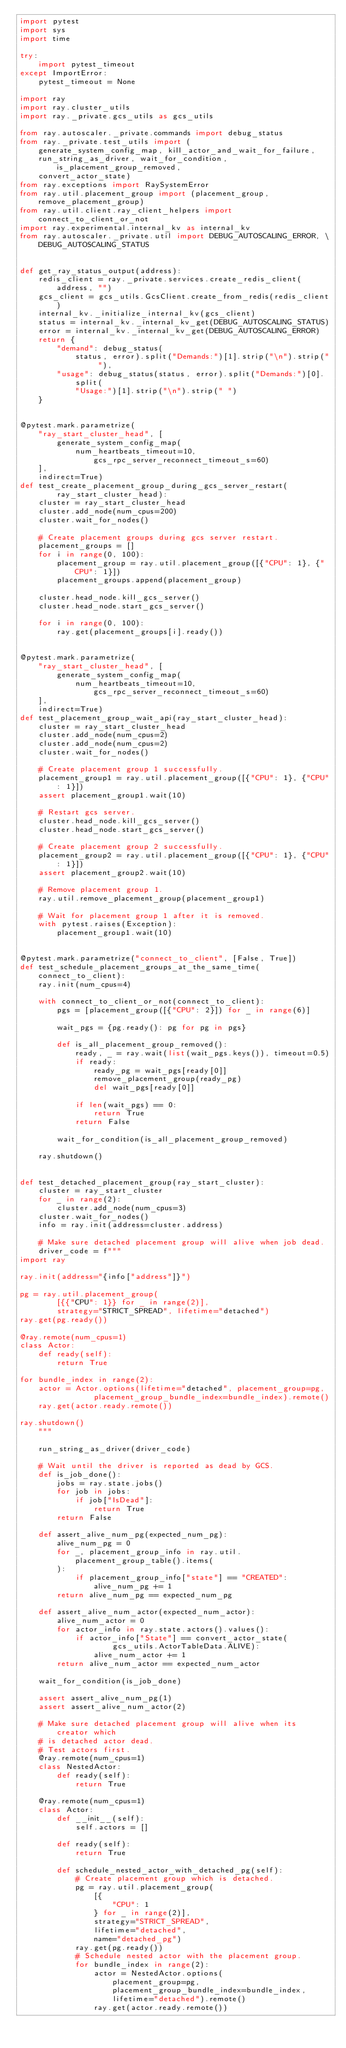<code> <loc_0><loc_0><loc_500><loc_500><_Python_>import pytest
import sys
import time

try:
    import pytest_timeout
except ImportError:
    pytest_timeout = None

import ray
import ray.cluster_utils
import ray._private.gcs_utils as gcs_utils

from ray.autoscaler._private.commands import debug_status
from ray._private.test_utils import (
    generate_system_config_map, kill_actor_and_wait_for_failure,
    run_string_as_driver, wait_for_condition, is_placement_group_removed,
    convert_actor_state)
from ray.exceptions import RaySystemError
from ray.util.placement_group import (placement_group, remove_placement_group)
from ray.util.client.ray_client_helpers import connect_to_client_or_not
import ray.experimental.internal_kv as internal_kv
from ray.autoscaler._private.util import DEBUG_AUTOSCALING_ERROR, \
    DEBUG_AUTOSCALING_STATUS


def get_ray_status_output(address):
    redis_client = ray._private.services.create_redis_client(address, "")
    gcs_client = gcs_utils.GcsClient.create_from_redis(redis_client)
    internal_kv._initialize_internal_kv(gcs_client)
    status = internal_kv._internal_kv_get(DEBUG_AUTOSCALING_STATUS)
    error = internal_kv._internal_kv_get(DEBUG_AUTOSCALING_ERROR)
    return {
        "demand": debug_status(
            status, error).split("Demands:")[1].strip("\n").strip(" "),
        "usage": debug_status(status, error).split("Demands:")[0].split(
            "Usage:")[1].strip("\n").strip(" ")
    }


@pytest.mark.parametrize(
    "ray_start_cluster_head", [
        generate_system_config_map(
            num_heartbeats_timeout=10, gcs_rpc_server_reconnect_timeout_s=60)
    ],
    indirect=True)
def test_create_placement_group_during_gcs_server_restart(
        ray_start_cluster_head):
    cluster = ray_start_cluster_head
    cluster.add_node(num_cpus=200)
    cluster.wait_for_nodes()

    # Create placement groups during gcs server restart.
    placement_groups = []
    for i in range(0, 100):
        placement_group = ray.util.placement_group([{"CPU": 1}, {"CPU": 1}])
        placement_groups.append(placement_group)

    cluster.head_node.kill_gcs_server()
    cluster.head_node.start_gcs_server()

    for i in range(0, 100):
        ray.get(placement_groups[i].ready())


@pytest.mark.parametrize(
    "ray_start_cluster_head", [
        generate_system_config_map(
            num_heartbeats_timeout=10, gcs_rpc_server_reconnect_timeout_s=60)
    ],
    indirect=True)
def test_placement_group_wait_api(ray_start_cluster_head):
    cluster = ray_start_cluster_head
    cluster.add_node(num_cpus=2)
    cluster.add_node(num_cpus=2)
    cluster.wait_for_nodes()

    # Create placement group 1 successfully.
    placement_group1 = ray.util.placement_group([{"CPU": 1}, {"CPU": 1}])
    assert placement_group1.wait(10)

    # Restart gcs server.
    cluster.head_node.kill_gcs_server()
    cluster.head_node.start_gcs_server()

    # Create placement group 2 successfully.
    placement_group2 = ray.util.placement_group([{"CPU": 1}, {"CPU": 1}])
    assert placement_group2.wait(10)

    # Remove placement group 1.
    ray.util.remove_placement_group(placement_group1)

    # Wait for placement group 1 after it is removed.
    with pytest.raises(Exception):
        placement_group1.wait(10)


@pytest.mark.parametrize("connect_to_client", [False, True])
def test_schedule_placement_groups_at_the_same_time(connect_to_client):
    ray.init(num_cpus=4)

    with connect_to_client_or_not(connect_to_client):
        pgs = [placement_group([{"CPU": 2}]) for _ in range(6)]

        wait_pgs = {pg.ready(): pg for pg in pgs}

        def is_all_placement_group_removed():
            ready, _ = ray.wait(list(wait_pgs.keys()), timeout=0.5)
            if ready:
                ready_pg = wait_pgs[ready[0]]
                remove_placement_group(ready_pg)
                del wait_pgs[ready[0]]

            if len(wait_pgs) == 0:
                return True
            return False

        wait_for_condition(is_all_placement_group_removed)

    ray.shutdown()


def test_detached_placement_group(ray_start_cluster):
    cluster = ray_start_cluster
    for _ in range(2):
        cluster.add_node(num_cpus=3)
    cluster.wait_for_nodes()
    info = ray.init(address=cluster.address)

    # Make sure detached placement group will alive when job dead.
    driver_code = f"""
import ray

ray.init(address="{info["address"]}")

pg = ray.util.placement_group(
        [{{"CPU": 1}} for _ in range(2)],
        strategy="STRICT_SPREAD", lifetime="detached")
ray.get(pg.ready())

@ray.remote(num_cpus=1)
class Actor:
    def ready(self):
        return True

for bundle_index in range(2):
    actor = Actor.options(lifetime="detached", placement_group=pg,
                placement_group_bundle_index=bundle_index).remote()
    ray.get(actor.ready.remote())

ray.shutdown()
    """

    run_string_as_driver(driver_code)

    # Wait until the driver is reported as dead by GCS.
    def is_job_done():
        jobs = ray.state.jobs()
        for job in jobs:
            if job["IsDead"]:
                return True
        return False

    def assert_alive_num_pg(expected_num_pg):
        alive_num_pg = 0
        for _, placement_group_info in ray.util.placement_group_table().items(
        ):
            if placement_group_info["state"] == "CREATED":
                alive_num_pg += 1
        return alive_num_pg == expected_num_pg

    def assert_alive_num_actor(expected_num_actor):
        alive_num_actor = 0
        for actor_info in ray.state.actors().values():
            if actor_info["State"] == convert_actor_state(
                    gcs_utils.ActorTableData.ALIVE):
                alive_num_actor += 1
        return alive_num_actor == expected_num_actor

    wait_for_condition(is_job_done)

    assert assert_alive_num_pg(1)
    assert assert_alive_num_actor(2)

    # Make sure detached placement group will alive when its creator which
    # is detached actor dead.
    # Test actors first.
    @ray.remote(num_cpus=1)
    class NestedActor:
        def ready(self):
            return True

    @ray.remote(num_cpus=1)
    class Actor:
        def __init__(self):
            self.actors = []

        def ready(self):
            return True

        def schedule_nested_actor_with_detached_pg(self):
            # Create placement group which is detached.
            pg = ray.util.placement_group(
                [{
                    "CPU": 1
                } for _ in range(2)],
                strategy="STRICT_SPREAD",
                lifetime="detached",
                name="detached_pg")
            ray.get(pg.ready())
            # Schedule nested actor with the placement group.
            for bundle_index in range(2):
                actor = NestedActor.options(
                    placement_group=pg,
                    placement_group_bundle_index=bundle_index,
                    lifetime="detached").remote()
                ray.get(actor.ready.remote())</code> 